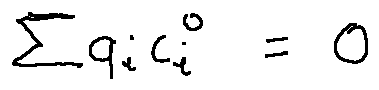Convert formula to latex. <formula><loc_0><loc_0><loc_500><loc_500>\sum q _ { i } c _ { i } ^ { 0 } = 0</formula> 